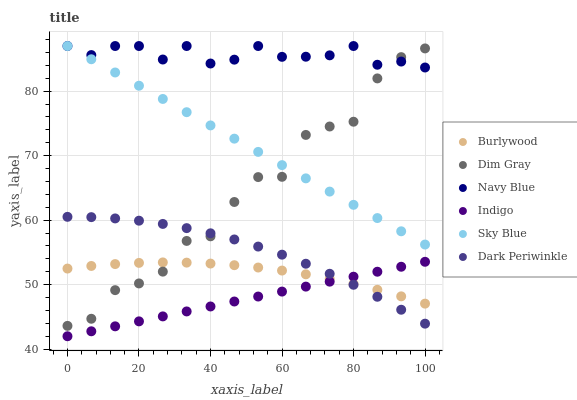Does Indigo have the minimum area under the curve?
Answer yes or no. Yes. Does Navy Blue have the maximum area under the curve?
Answer yes or no. Yes. Does Burlywood have the minimum area under the curve?
Answer yes or no. No. Does Burlywood have the maximum area under the curve?
Answer yes or no. No. Is Sky Blue the smoothest?
Answer yes or no. Yes. Is Dim Gray the roughest?
Answer yes or no. Yes. Is Indigo the smoothest?
Answer yes or no. No. Is Indigo the roughest?
Answer yes or no. No. Does Indigo have the lowest value?
Answer yes or no. Yes. Does Burlywood have the lowest value?
Answer yes or no. No. Does Sky Blue have the highest value?
Answer yes or no. Yes. Does Indigo have the highest value?
Answer yes or no. No. Is Indigo less than Sky Blue?
Answer yes or no. Yes. Is Navy Blue greater than Burlywood?
Answer yes or no. Yes. Does Burlywood intersect Indigo?
Answer yes or no. Yes. Is Burlywood less than Indigo?
Answer yes or no. No. Is Burlywood greater than Indigo?
Answer yes or no. No. Does Indigo intersect Sky Blue?
Answer yes or no. No. 